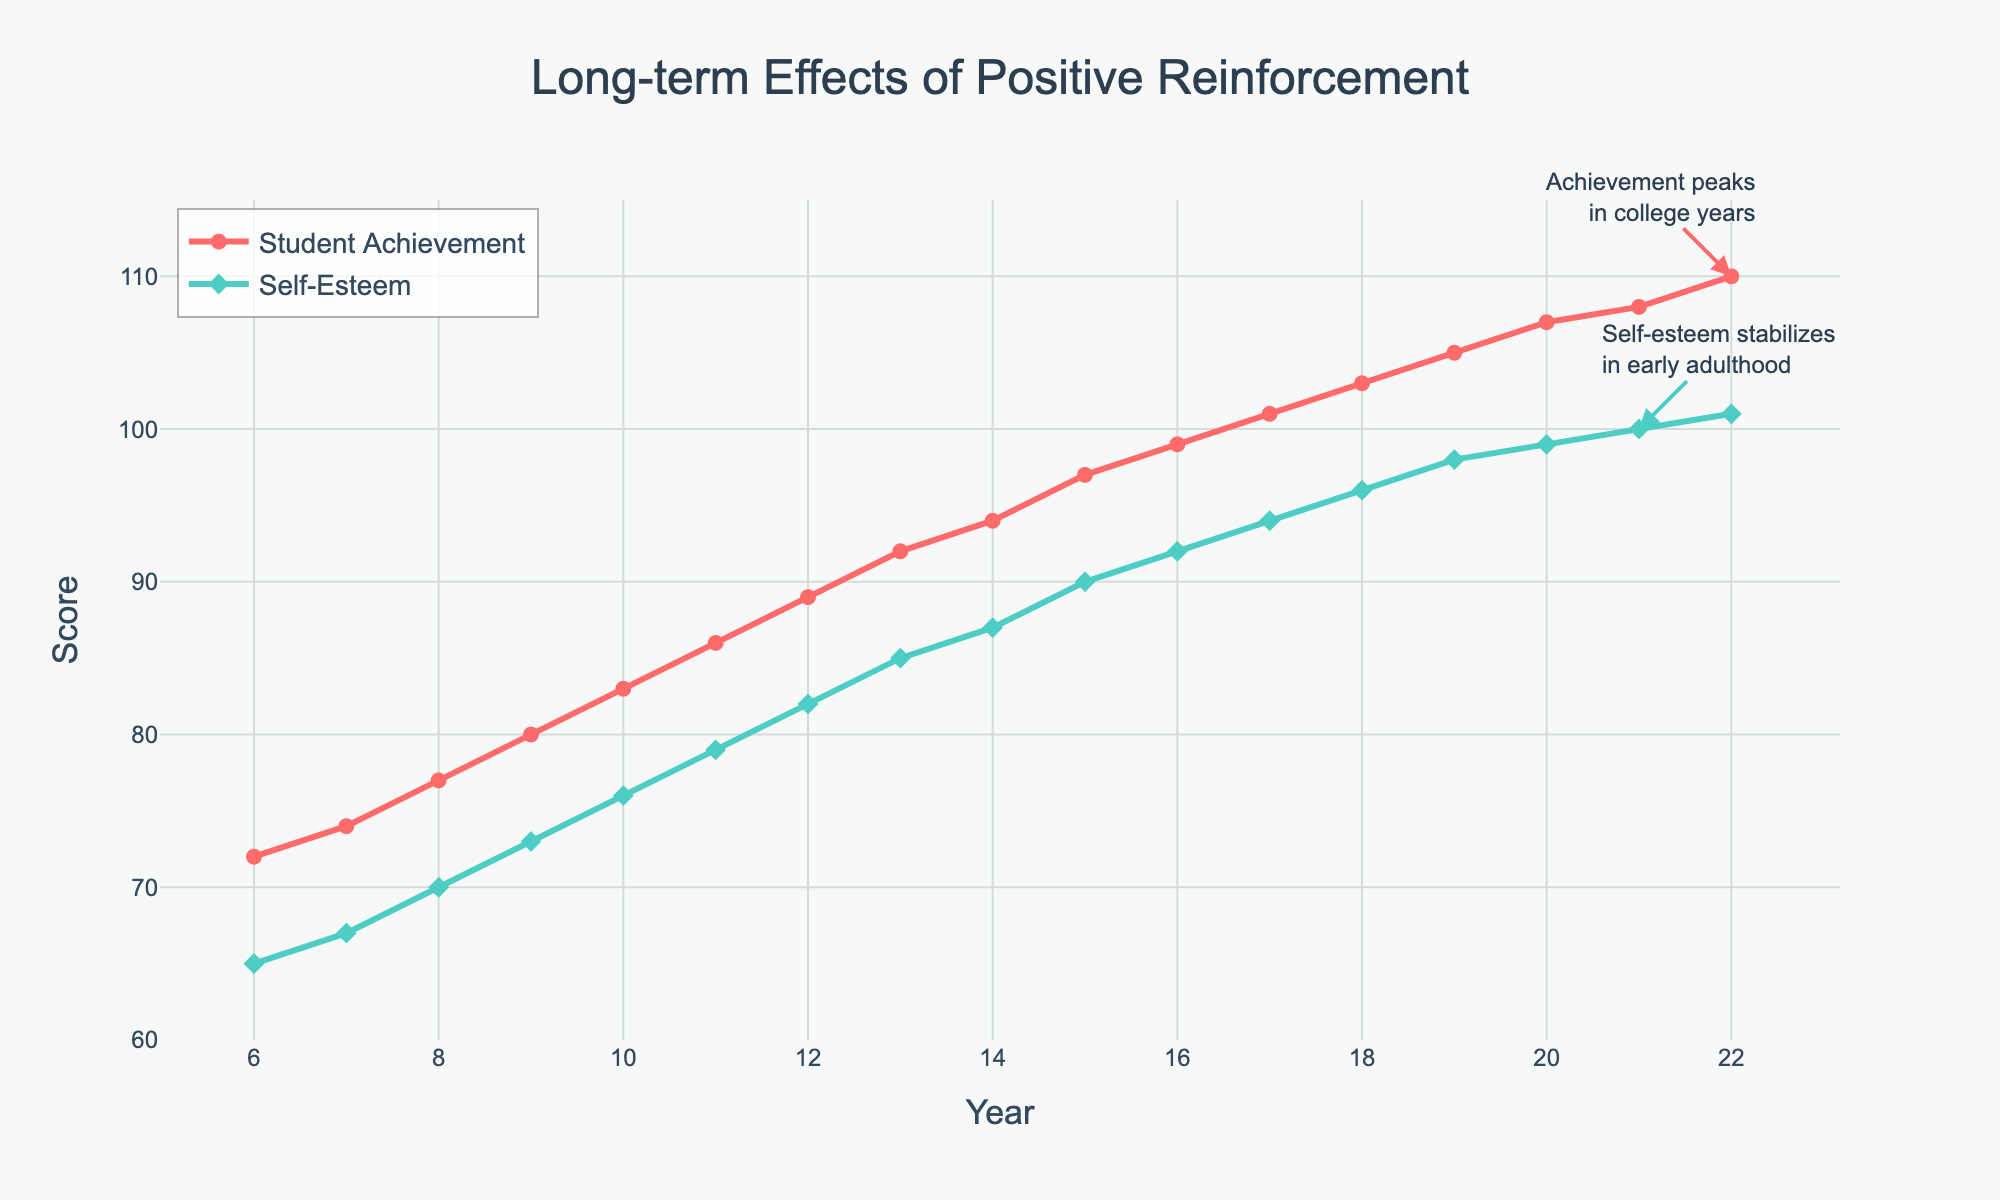What is the range of Student Achievement Scores from year 6 to year 22? The lowest Student Achievement Score is 72 at year 6, and the highest is 110 at year 22. The range is calculated as 110 - 72.
Answer: 38 Which score increases more rapidly between years 10 and 12, Student Achievement or Self-Esteem? From year 10 to year 12, the Student Achievement Score increases from 83 to 89, which is an increase of 6 points. The Self-Esteem Score increases from 76 to 82, also an increase of 6 points. Therefore, they increase at the same rate.
Answer: Both increase equally At what year do both Student Achievement and Self-Esteem Scores first reach or exceed 90? By closely inspecting the plot, we see that Student Achievement reaches 90 by year 15, and Self-Esteem reaches 90 by year 18. The first year both scores are at least 90 is year 18.
Answer: Year 18 Compare the difference between Student Achievement and Self-Esteem Scores in year 9 and year 19. Has the difference increased or decreased? In year 9, the difference is 80 (Student Achievement) - 73 (Self-Esteem) = 7. In year 19, the difference is 105 - 98 = 7. So, the difference remained the same.
Answer: Remained the same Which score stabilizes sooner, Student Achievement or Self-Esteem? We can infer stabilization by looking at the slope of the lines. The Student Achievement Score continues to increase slowly until year 22, whereas Self-Esteem appears to stabilize around year 21. Therefore, Self-Esteem stabilizes sooner.
Answer: Self-Esteem Between which years is the greatest increase in Self-Esteem Score observed? By examining the slope of Self-Esteem Score, the greatest increase appears between years 6 and 7, where the Self-Esteem Score increases from 65 to 67, a difference of 2 points.
Answer: Between years 6 and 7 At what year does the Student Achievement Score trend show an annotation, and what does it signify? There is an annotation at year 22, indicating that Achievement peaks in the college years, with a score of 110.
Answer: Year 22, peaks in college years What is the average score for Student Achievement from year 6 to year 22? Sum the Student Achievement Scores from year 6 to year 22 and divide by the number of years to find the average. (72+74+77+80+83+86+89+92+94+97+99+101+103+105+107+108+110) / 17 = 93.94
Answer: 93.94 